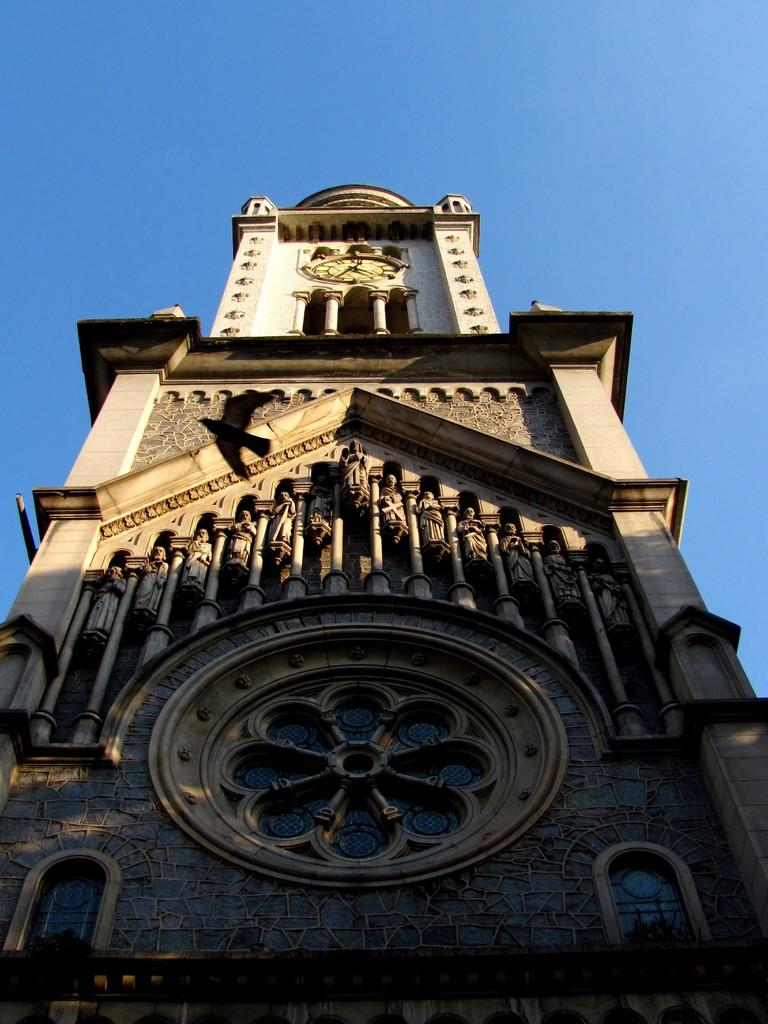What is the main structure in the center of the image? There is a clock tower in the center of the image. What can be seen at the top of the image? The sky is visible at the top of the image. Where is the mother in the image? There is no mother present in the image; it only features a clock tower and the sky. What type of cloth is draped over the kettle in the image? There is no kettle or cloth present in the image. 